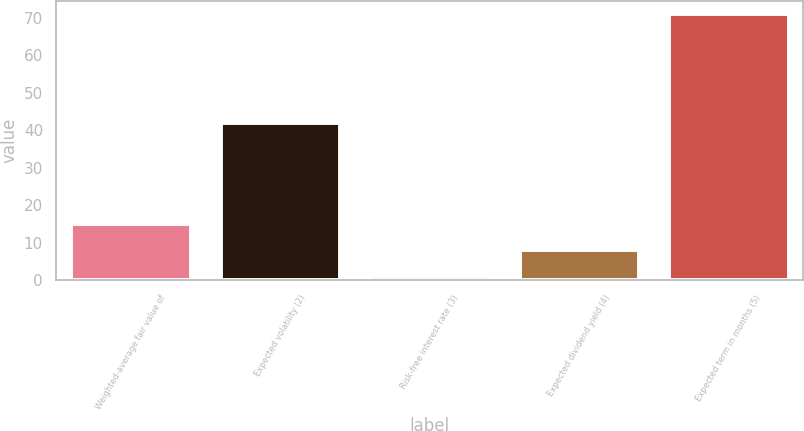Convert chart. <chart><loc_0><loc_0><loc_500><loc_500><bar_chart><fcel>Weighted-average fair value of<fcel>Expected volatility (2)<fcel>Risk-free interest rate (3)<fcel>Expected dividend yield (4)<fcel>Expected term in months (5)<nl><fcel>15.05<fcel>42<fcel>1.07<fcel>8.06<fcel>71<nl></chart> 